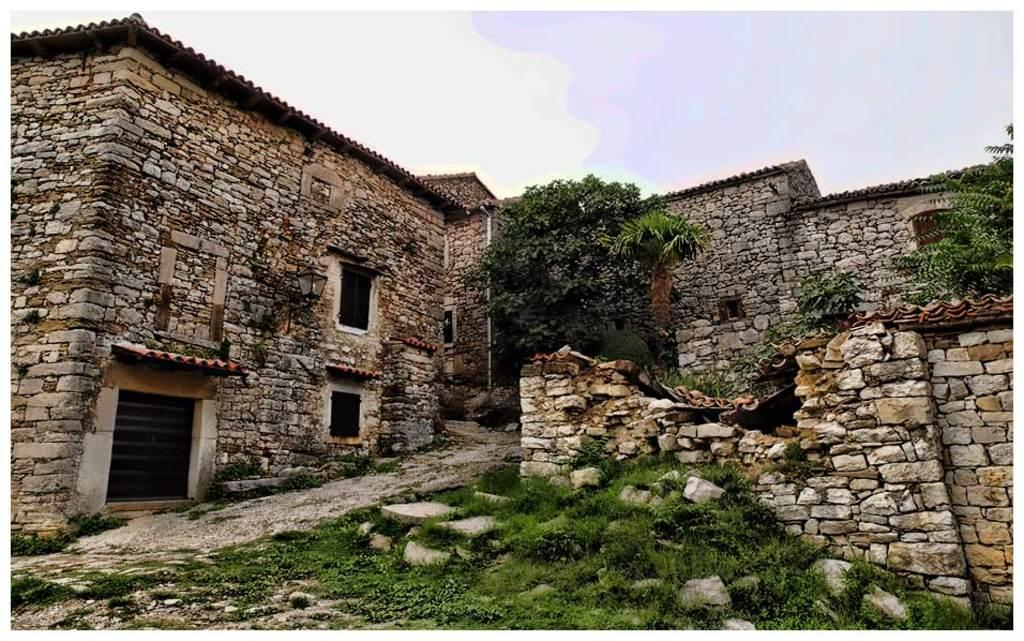What type of structures can be seen in the image? There are buildings in the image. What other natural elements are present in the image? There are trees in the image. What can be seen in the distance in the image? The sky is visible in the background of the image. What type of feast is being held in the image? There is no feast present in the image; it features buildings, trees, and the sky. 